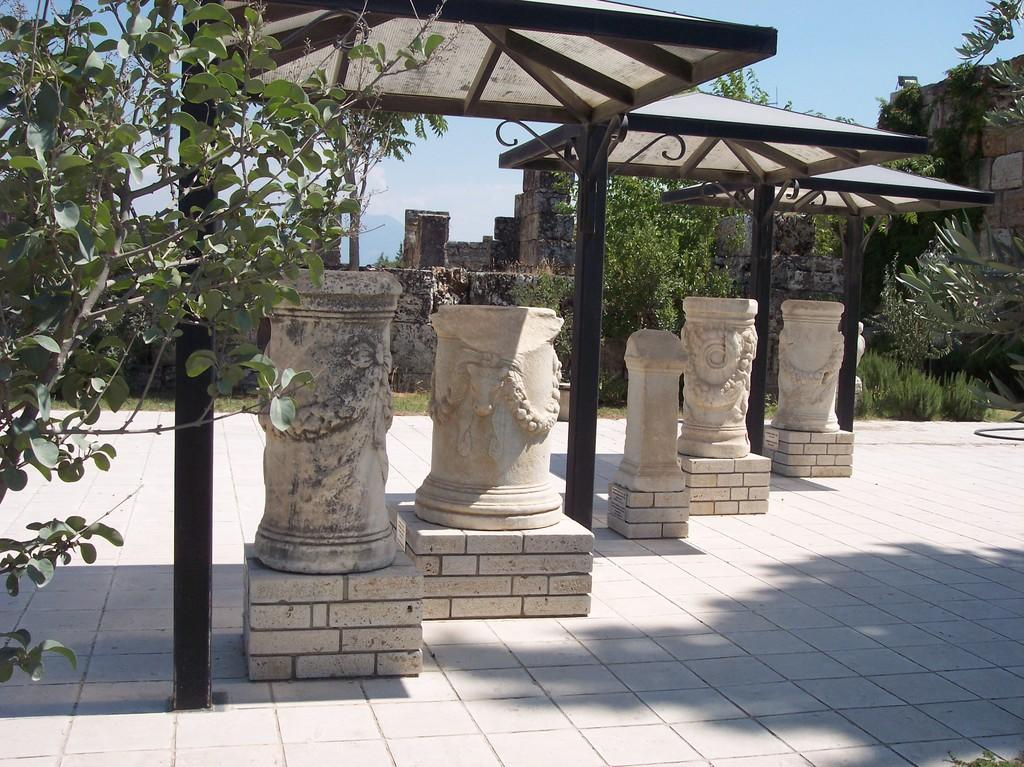What type of artwork can be seen in the image? There are sculptures in the image. What other elements are present in the image besides the sculptures? There are plants and trees in the image. What architectural feature can be seen in the image? There is a wall in the image. What is visible in the background of the image? The sky is visible in the image. What color are the teeth of the sculpture in the image? There are no teeth present on the sculptures in the image. 